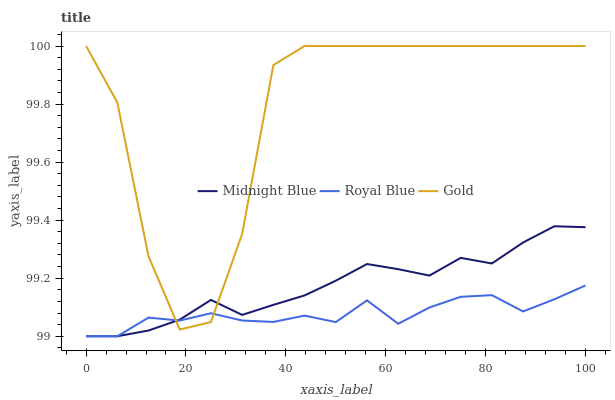Does Royal Blue have the minimum area under the curve?
Answer yes or no. Yes. Does Gold have the maximum area under the curve?
Answer yes or no. Yes. Does Midnight Blue have the minimum area under the curve?
Answer yes or no. No. Does Midnight Blue have the maximum area under the curve?
Answer yes or no. No. Is Midnight Blue the smoothest?
Answer yes or no. Yes. Is Gold the roughest?
Answer yes or no. Yes. Is Gold the smoothest?
Answer yes or no. No. Is Midnight Blue the roughest?
Answer yes or no. No. Does Royal Blue have the lowest value?
Answer yes or no. Yes. Does Gold have the lowest value?
Answer yes or no. No. Does Gold have the highest value?
Answer yes or no. Yes. Does Midnight Blue have the highest value?
Answer yes or no. No. Does Gold intersect Midnight Blue?
Answer yes or no. Yes. Is Gold less than Midnight Blue?
Answer yes or no. No. Is Gold greater than Midnight Blue?
Answer yes or no. No. 